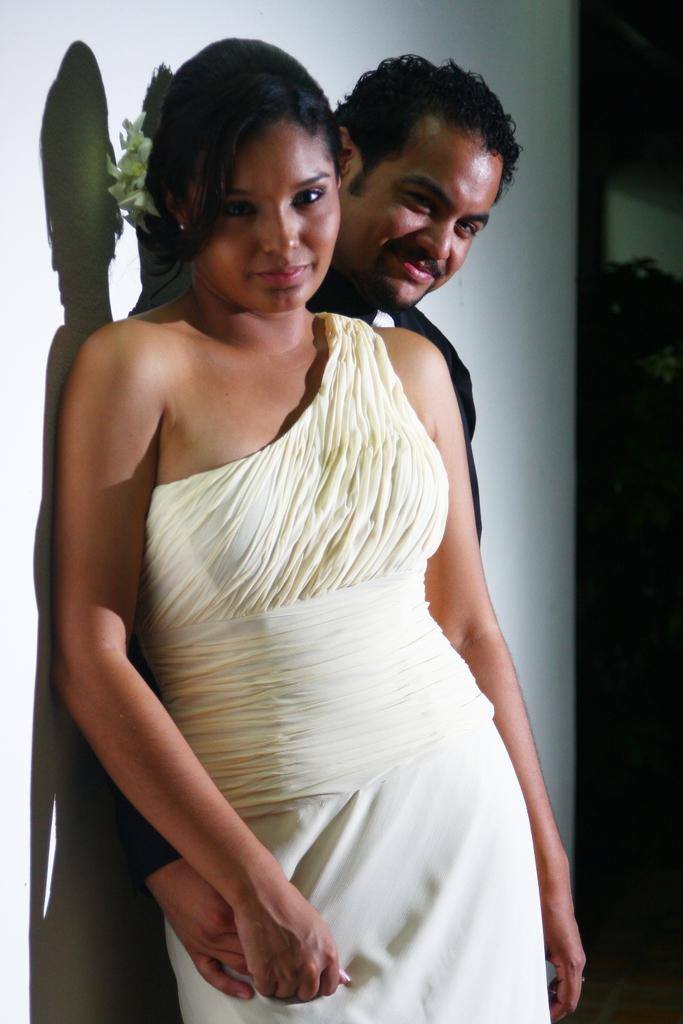Who are the people in the image? There is a woman and a man in the image. What are the expressions on their faces? Both the woman and the man are smiling in the image. Where are they positioned in the image? They are leaning against a wall. What type of beef is being served to the passenger in the image? There is no passenger or beef present in the image; it features a woman and a man leaning against a wall and smiling. 